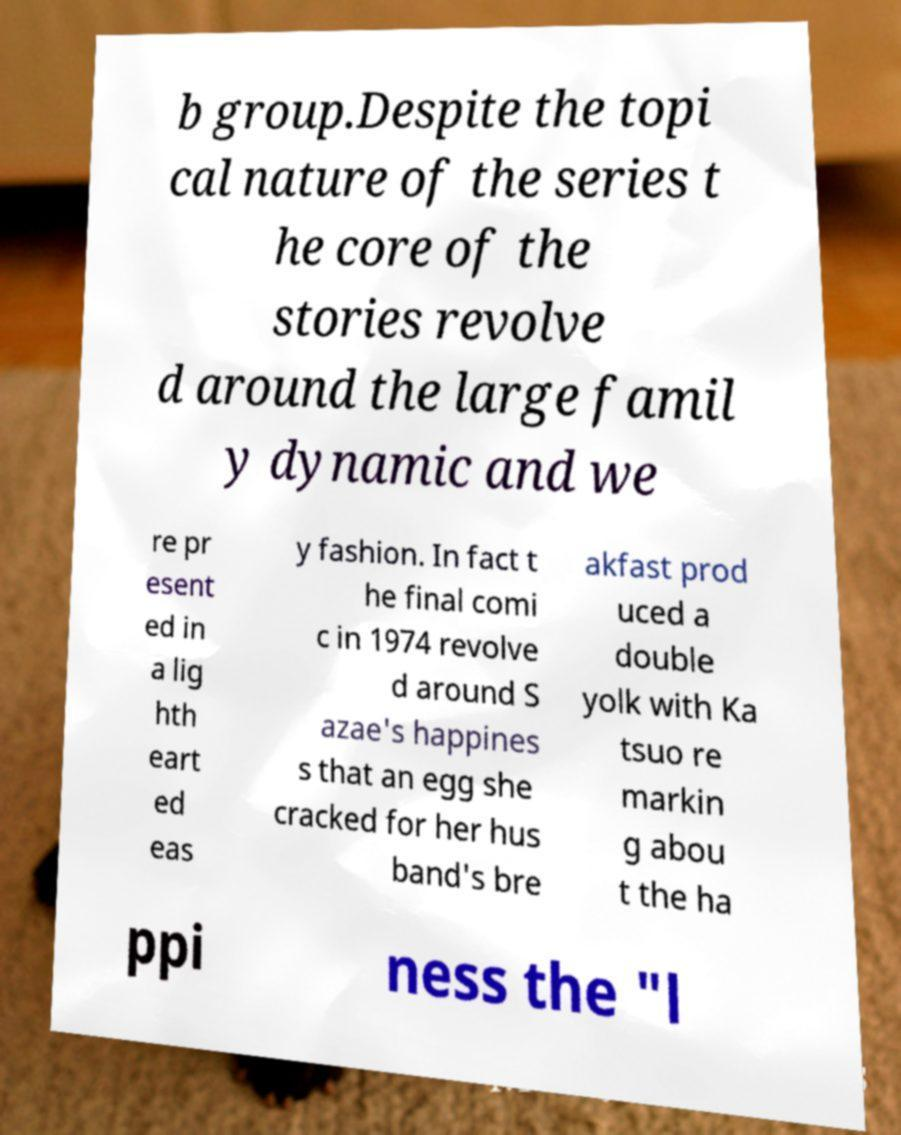I need the written content from this picture converted into text. Can you do that? b group.Despite the topi cal nature of the series t he core of the stories revolve d around the large famil y dynamic and we re pr esent ed in a lig hth eart ed eas y fashion. In fact t he final comi c in 1974 revolve d around S azae's happines s that an egg she cracked for her hus band's bre akfast prod uced a double yolk with Ka tsuo re markin g abou t the ha ppi ness the "l 